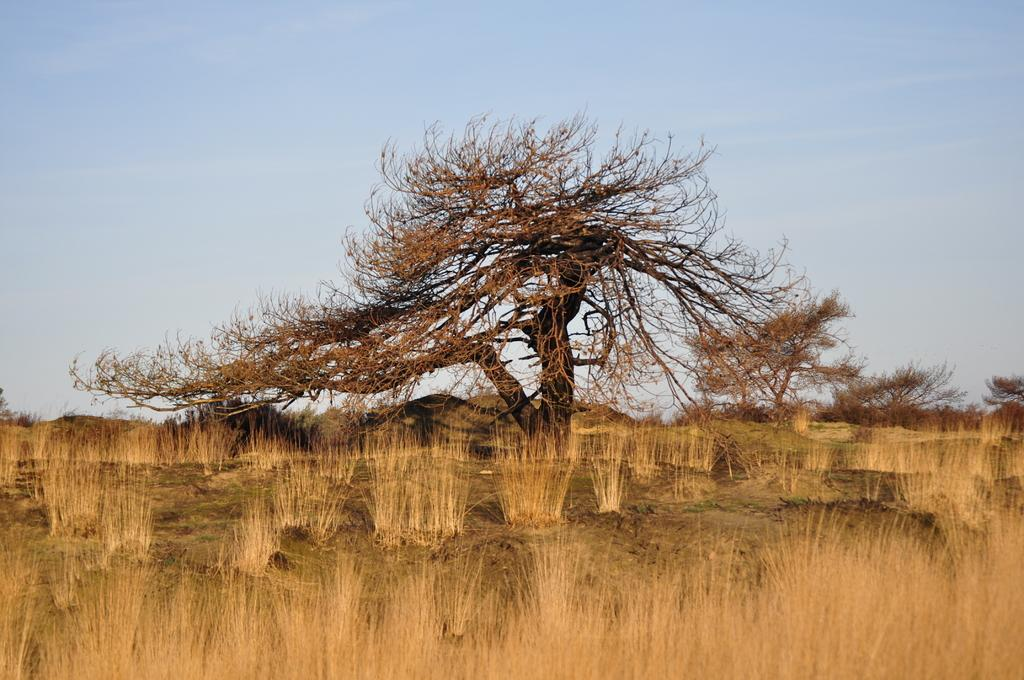What type of vegetation is located at the bottom of the image? There are bushes on the bottom side of the image. What can be seen in the center of the image? There are trees in the center of the image. What is visible in the background of the image? The sky is visible in the background of the image. Where can you purchase a ticket for the band's performance in the image? There is no band or ticket present in the image; it features bushes, trees, and the sky. What type of powder is being used by the people in the image? There are no people or powder present in the image. 